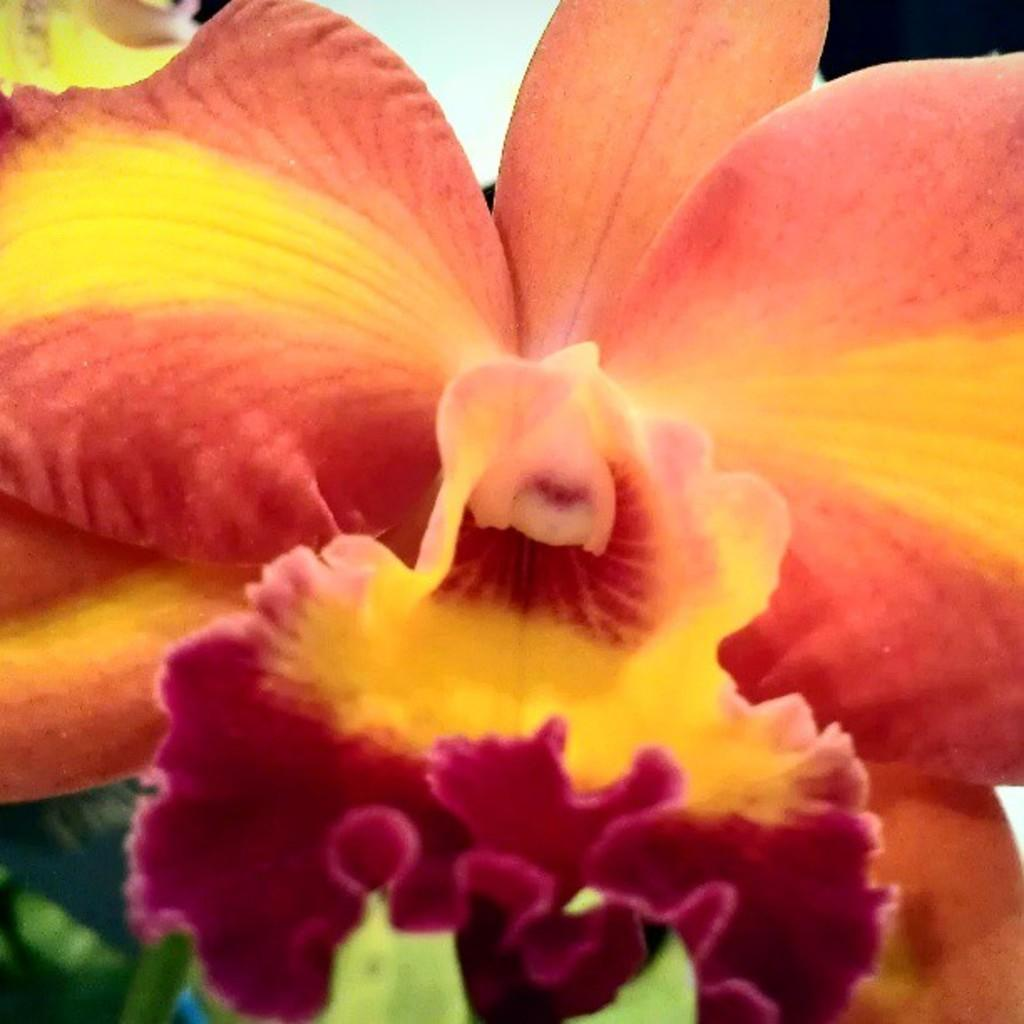What is the main subject of the image? There is a flower in the image. How many cars are parked next to the flower in the image? There are no cars present in the image; it only features a flower. What type of cactus can be seen growing near the flower in the image? There is no cactus present in the image; it only features a flower. 